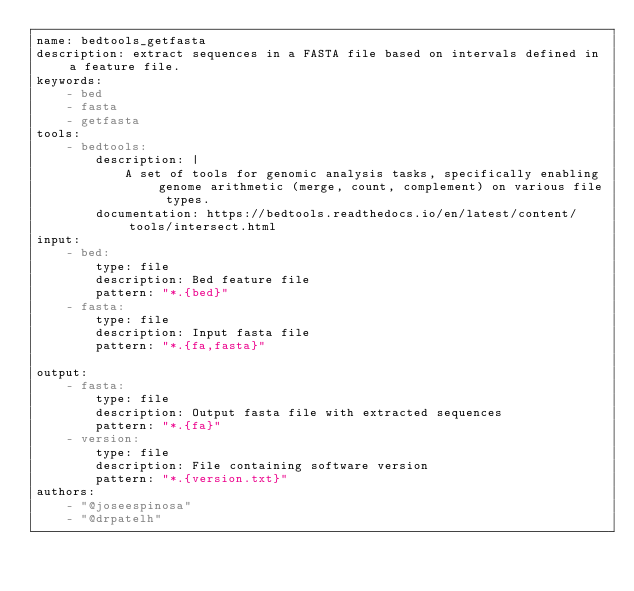<code> <loc_0><loc_0><loc_500><loc_500><_YAML_>name: bedtools_getfasta
description: extract sequences in a FASTA file based on intervals defined in a feature file.
keywords:
    - bed
    - fasta
    - getfasta
tools:
    - bedtools:
        description: |
            A set of tools for genomic analysis tasks, specifically enabling genome arithmetic (merge, count, complement) on various file types.
        documentation: https://bedtools.readthedocs.io/en/latest/content/tools/intersect.html
input:
    - bed:
        type: file
        description: Bed feature file
        pattern: "*.{bed}"
    - fasta:
        type: file
        description: Input fasta file
        pattern: "*.{fa,fasta}"

output:
    - fasta:
        type: file
        description: Output fasta file with extracted sequences
        pattern: "*.{fa}"
    - version:
        type: file
        description: File containing software version
        pattern: "*.{version.txt}"
authors:
    - "@joseespinosa"
    - "@drpatelh"
</code> 